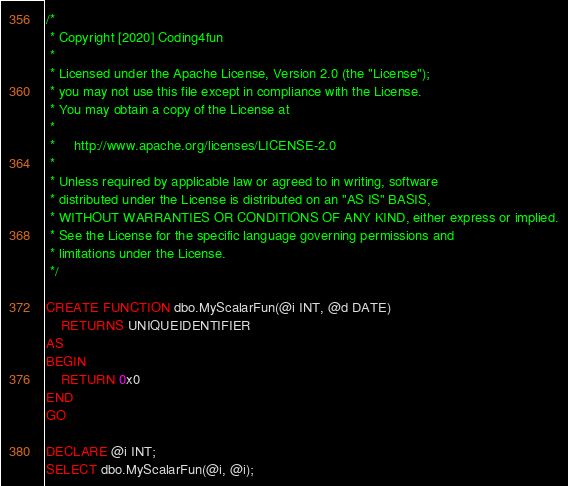Convert code to text. <code><loc_0><loc_0><loc_500><loc_500><_SQL_>/*
 * Copyright [2020] Coding4fun
 *
 * Licensed under the Apache License, Version 2.0 (the "License");
 * you may not use this file except in compliance with the License.
 * You may obtain a copy of the License at
 *
 *     http://www.apache.org/licenses/LICENSE-2.0
 *
 * Unless required by applicable law or agreed to in writing, software
 * distributed under the License is distributed on an "AS IS" BASIS,
 * WITHOUT WARRANTIES OR CONDITIONS OF ANY KIND, either express or implied.
 * See the License for the specific language governing permissions and
 * limitations under the License.
 */

CREATE FUNCTION dbo.MyScalarFun(@i INT, @d DATE)
    RETURNS UNIQUEIDENTIFIER
AS
BEGIN
    RETURN 0x0
END
GO

DECLARE @i INT;
SELECT dbo.MyScalarFun(@i, @i);</code> 